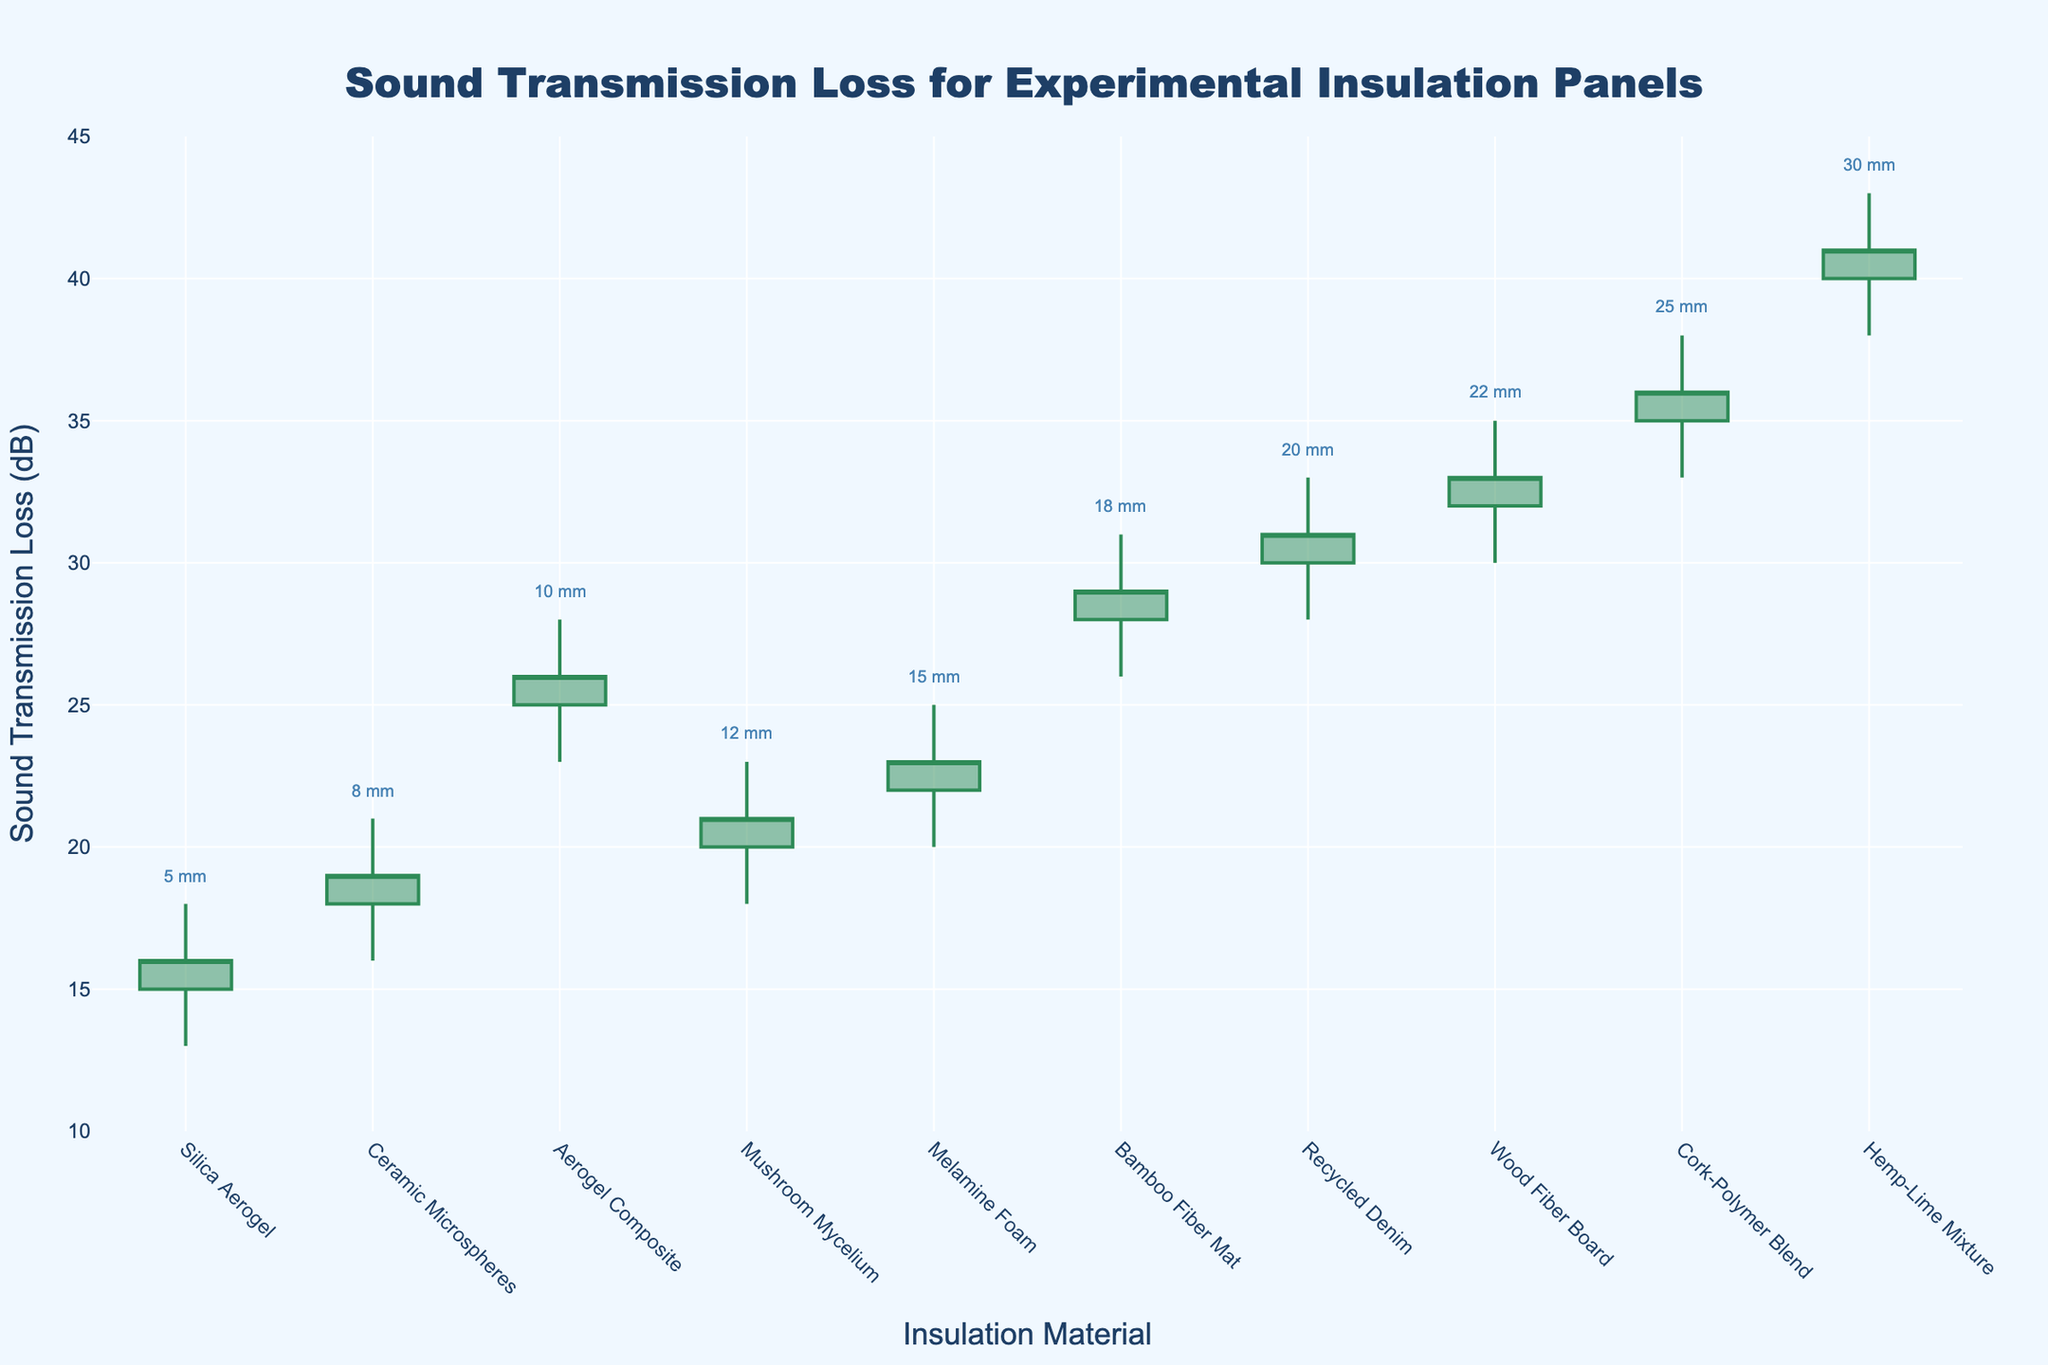What is the title of the chart? The title is displayed at the top of the chart, centered, and reads "Sound Transmission Loss for Experimental Insulation Panels"
Answer: Sound Transmission Loss for Experimental Insulation Panels Which material has the highest sound transmission loss? By observing the highest points on the chart, Hemp-Lime Mixture has the highest high value, which reaches 43 dB
Answer: Hemp-Lime Mixture What is the range of sound transmission loss for Melamine Foam? The range is determined by subtracting the low value from the high value. For Melamine Foam, it is 25 dB (high) - 20 dB (low) = 5 dB
Answer: 5 dB Which materials have a closing sound transmission loss of 26 dB? By checking each material's closing value, Aerogel Composite and Bamboo Fiber Mat both have a closing value of 26 dB
Answer: Aerogel Composite, Bamboo Fiber Mat What is the average opening sound transmission loss of the first three materials in terms of thickness? The first three materials sorted by thickness are Silica Aerogel, Ceramic Microspheres, and Mushroom Mycelium. Their opening values are 15, 18, and 20 dB respectively. The average is (15 + 18 + 20) / 3 = 17.67 dB
Answer: 17.67 dB How does the sound transmission loss for Silica Aerogel compare to Ceramic Microspheres in terms of variability? The difference between high and low values indicates the variability. Silica Aerogel has (18 - 13) = 5 dB, and Ceramic Microspheres has (21 - 16) = 5 dB. Both have the same variability
Answer: Same Which material has the lowest high value, and what is it? By examining all high values, Silica Aerogel has the lowest high value of 18 dB
Answer: Silica Aerogel What's the difference in thickness between the materials with the highest and the lowest high values? Hemp-Lime Mixture has the highest high value at 43 dB with 30 mm thickness and Silica Aerogel has the lowest high value at 18 dB with 5 mm thickness. The difference in thickness is 30 - 5 = 25 mm
Answer: 25 mm What is the sound transmission loss of Cork-Polymer Blend when it opens and closes? The opening value for Cork-Polymer Blend is 35 dB and the closing value is 36 dB
Answer: 35 dB (open), 36 dB (close) Is the close value of Recycled Denim higher than the open value of Wood Fiber Board? Recycled Denim closes at 31 dB and Wood Fiber Board opens at 32 dB. 31 dB is not higher than 32 dB
Answer: No 